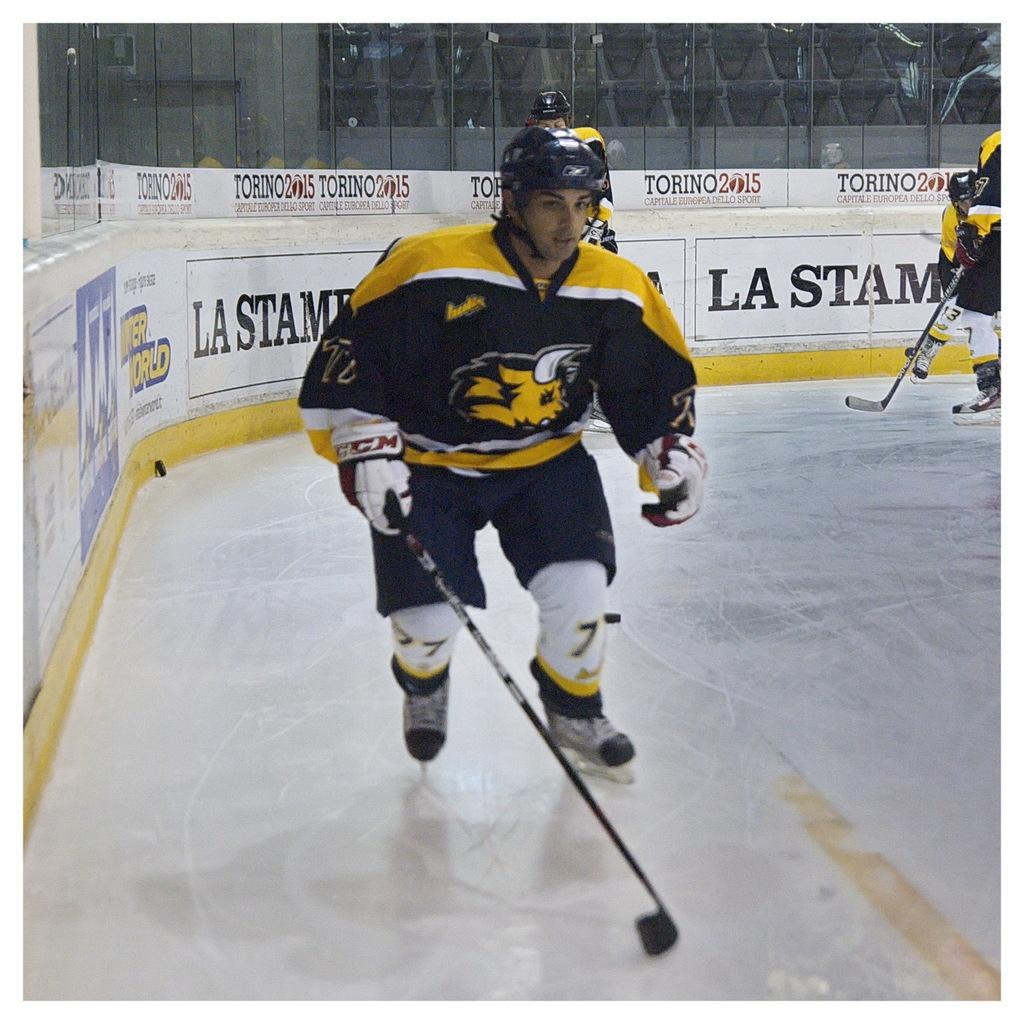What activity are the people in the center of the image engaged in? The people in the center of the image are ice skating. What safety equipment are the people wearing while ice skating? The people are wearing helmets. What can be seen in the background of the image? There are banners and glass visible in the background of the image. What type of skirt is the fireman wearing in the image? There is no fireman or skirt present in the image. The people in the image are ice skating and wearing helmets. 